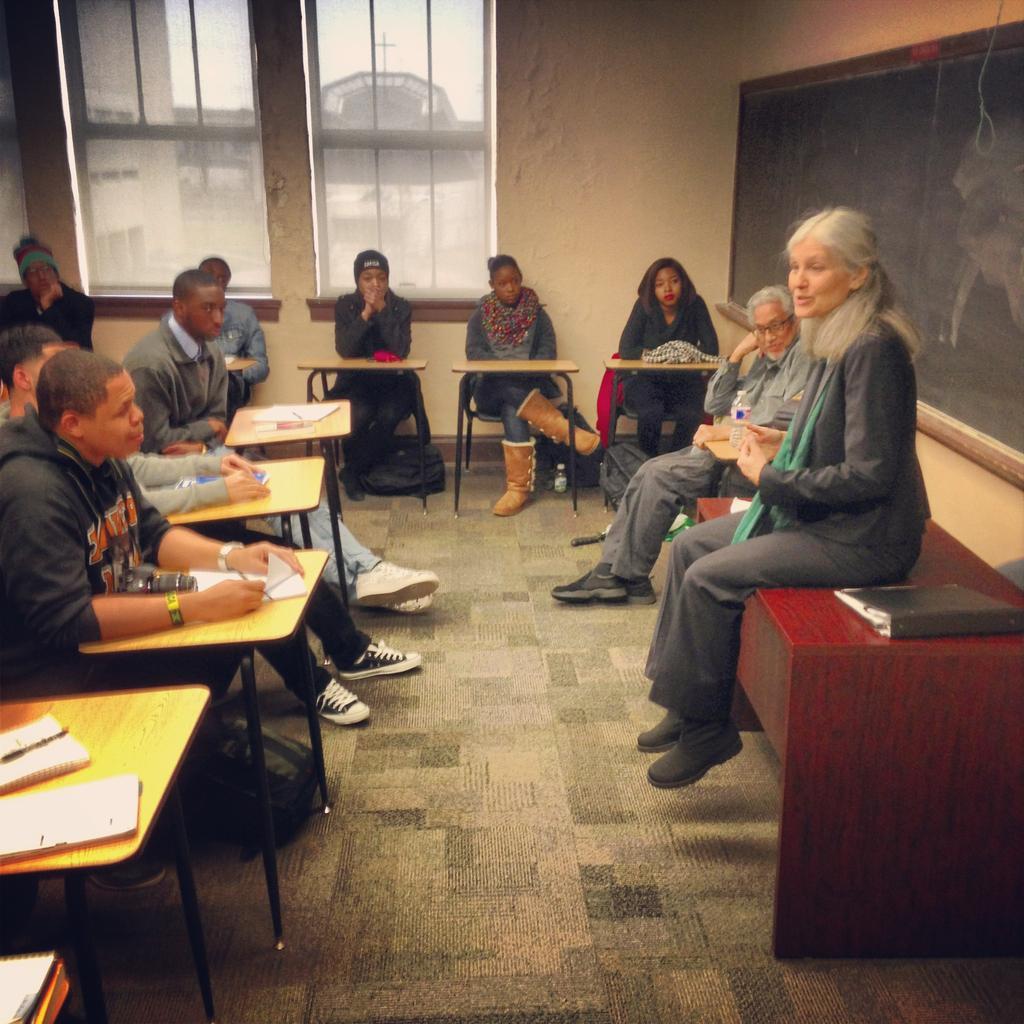Describe this image in one or two sentences. In this picture we can see some people sitting on the chairs and a lady sitting on the desk in front of them. 